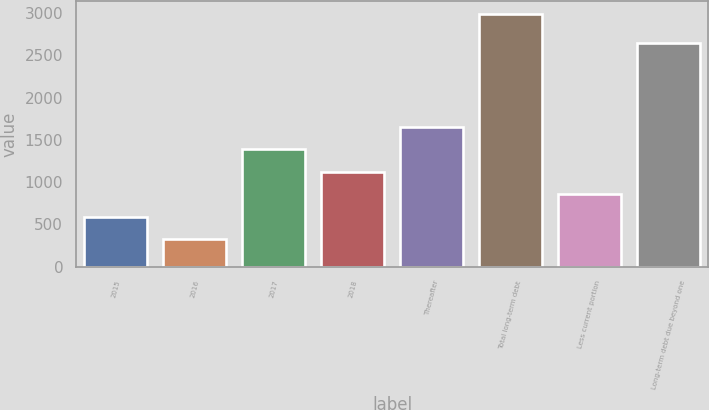Convert chart. <chart><loc_0><loc_0><loc_500><loc_500><bar_chart><fcel>2015<fcel>2016<fcel>2017<fcel>2018<fcel>Thereafter<fcel>Total long-term debt<fcel>Less current portion<fcel>Long-term debt due beyond one<nl><fcel>591.24<fcel>325<fcel>1389.96<fcel>1123.72<fcel>1656.2<fcel>2987.4<fcel>857.48<fcel>2643.5<nl></chart> 